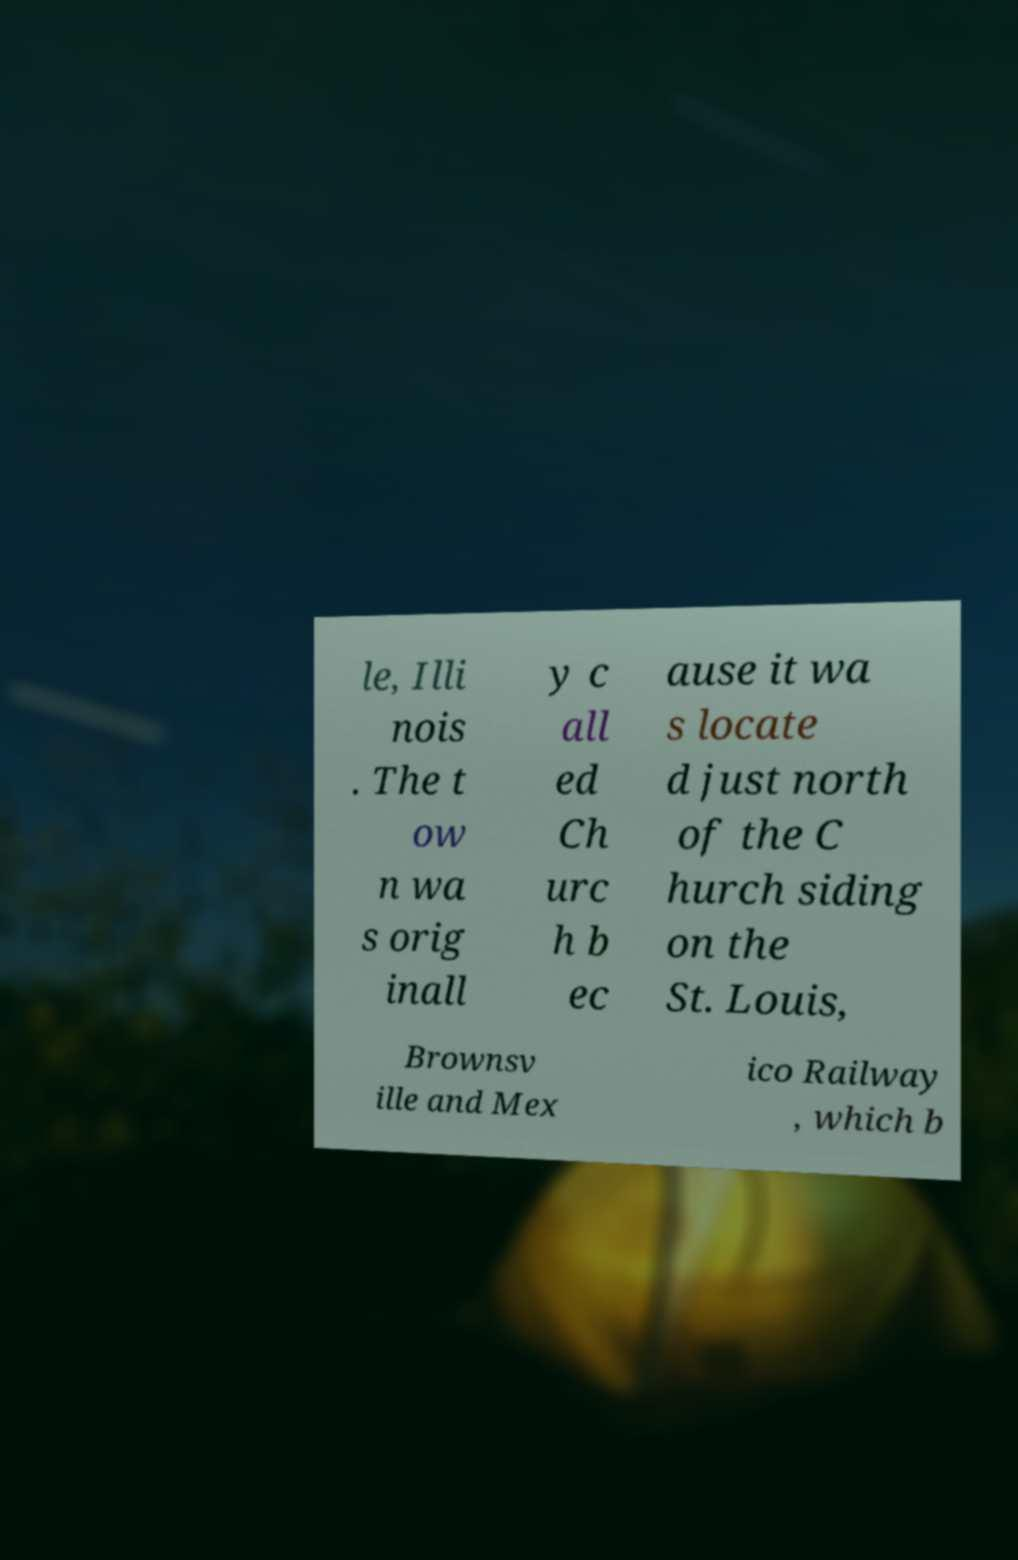Can you accurately transcribe the text from the provided image for me? le, Illi nois . The t ow n wa s orig inall y c all ed Ch urc h b ec ause it wa s locate d just north of the C hurch siding on the St. Louis, Brownsv ille and Mex ico Railway , which b 